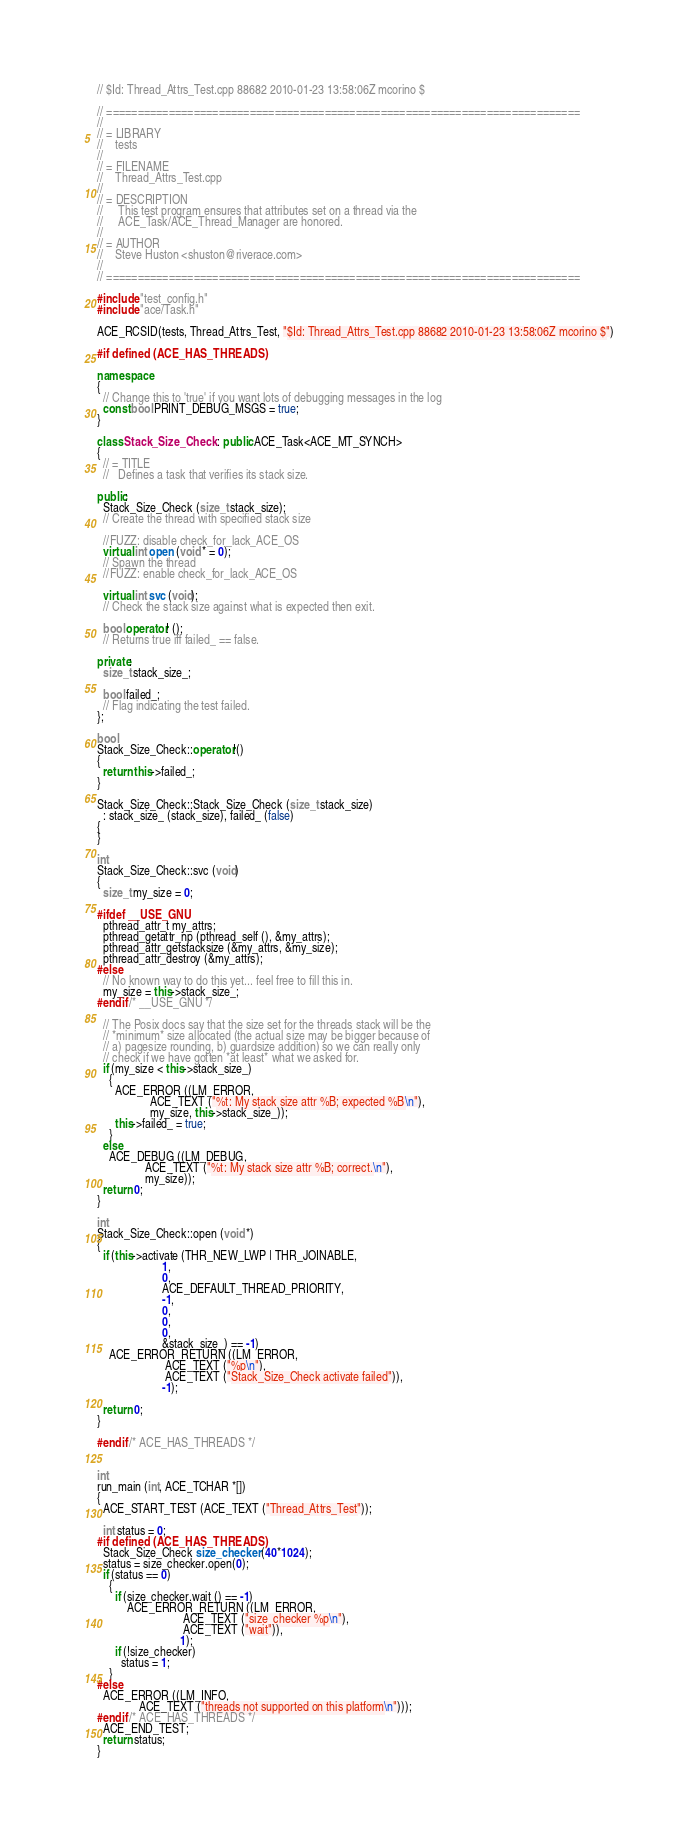Convert code to text. <code><loc_0><loc_0><loc_500><loc_500><_C++_>// $Id: Thread_Attrs_Test.cpp 88682 2010-01-23 13:58:06Z mcorino $

// ============================================================================
//
// = LIBRARY
//    tests
//
// = FILENAME
//    Thread_Attrs_Test.cpp
//
// = DESCRIPTION
//     This test program ensures that attributes set on a thread via the
//     ACE_Task/ACE_Thread_Manager are honored.
//
// = AUTHOR
//    Steve Huston <shuston@riverace.com>
//
// ============================================================================

#include "test_config.h"
#include "ace/Task.h"

ACE_RCSID(tests, Thread_Attrs_Test, "$Id: Thread_Attrs_Test.cpp 88682 2010-01-23 13:58:06Z mcorino $")

#if defined (ACE_HAS_THREADS)

namespace
{
  // Change this to 'true' if you want lots of debugging messages in the log
  const bool PRINT_DEBUG_MSGS = true;
}

class Stack_Size_Check : public ACE_Task<ACE_MT_SYNCH>
{
  // = TITLE
  //   Defines a task that verifies its stack size.

public:
  Stack_Size_Check (size_t stack_size);
  // Create the thread with specified stack size

  //FUZZ: disable check_for_lack_ACE_OS
  virtual int open (void * = 0);
  // Spawn the thread
  //FUZZ: enable check_for_lack_ACE_OS

  virtual int svc (void);
  // Check the stack size against what is expected then exit.

  bool operator! ();
  // Returns true iff failed_ == false.

private:
  size_t stack_size_;

  bool failed_;
  // Flag indicating the test failed.
};

bool
Stack_Size_Check::operator!()
{
  return this->failed_;
}

Stack_Size_Check::Stack_Size_Check (size_t stack_size)
  : stack_size_ (stack_size), failed_ (false)
{
}

int
Stack_Size_Check::svc (void)
{
  size_t my_size = 0;

#ifdef __USE_GNU
  pthread_attr_t my_attrs;
  pthread_getattr_np (pthread_self (), &my_attrs);
  pthread_attr_getstacksize (&my_attrs, &my_size);
  pthread_attr_destroy (&my_attrs);
#else
  // No known way to do this yet... feel free to fill this in.
  my_size = this->stack_size_;
#endif /* __USE_GNU */

  // The Posix docs say that the size set for the threads stack will be the
  // *minimum* size allocated (the actual size may be bigger because of
  // a) pagesize rounding, b) guardsize addition) so we can really only
  // check if we have gotten *at least* what we asked for.
  if (my_size < this->stack_size_)
    {
      ACE_ERROR ((LM_ERROR,
                  ACE_TEXT ("%t: My stack size attr %B; expected %B\n"),
                  my_size, this->stack_size_));
      this->failed_ = true;
    }
  else
    ACE_DEBUG ((LM_DEBUG,
                ACE_TEXT ("%t: My stack size attr %B; correct.\n"),
                my_size));
  return 0;
}

int
Stack_Size_Check::open (void *)
{
  if (this->activate (THR_NEW_LWP | THR_JOINABLE,
                      1,
                      0,
                      ACE_DEFAULT_THREAD_PRIORITY,
                      -1,
                      0,
                      0,
                      0,
                      &stack_size_) == -1)
    ACE_ERROR_RETURN ((LM_ERROR,
                       ACE_TEXT ("%p\n"),
                       ACE_TEXT ("Stack_Size_Check activate failed")),
                      -1);

  return 0;
}

#endif /* ACE_HAS_THREADS */


int
run_main (int, ACE_TCHAR *[])
{
  ACE_START_TEST (ACE_TEXT ("Thread_Attrs_Test"));

  int status = 0;
#if defined (ACE_HAS_THREADS)
  Stack_Size_Check size_checker (40*1024);
  status = size_checker.open(0);
  if (status == 0)
    {
      if (size_checker.wait () == -1)
          ACE_ERROR_RETURN ((LM_ERROR,
                             ACE_TEXT ("size_checker %p\n"),
                             ACE_TEXT ("wait")),
                            1);
      if (!size_checker)
        status = 1;
    }
#else
  ACE_ERROR ((LM_INFO,
              ACE_TEXT ("threads not supported on this platform\n")));
#endif /* ACE_HAS_THREADS */
  ACE_END_TEST;
  return status;
}
</code> 